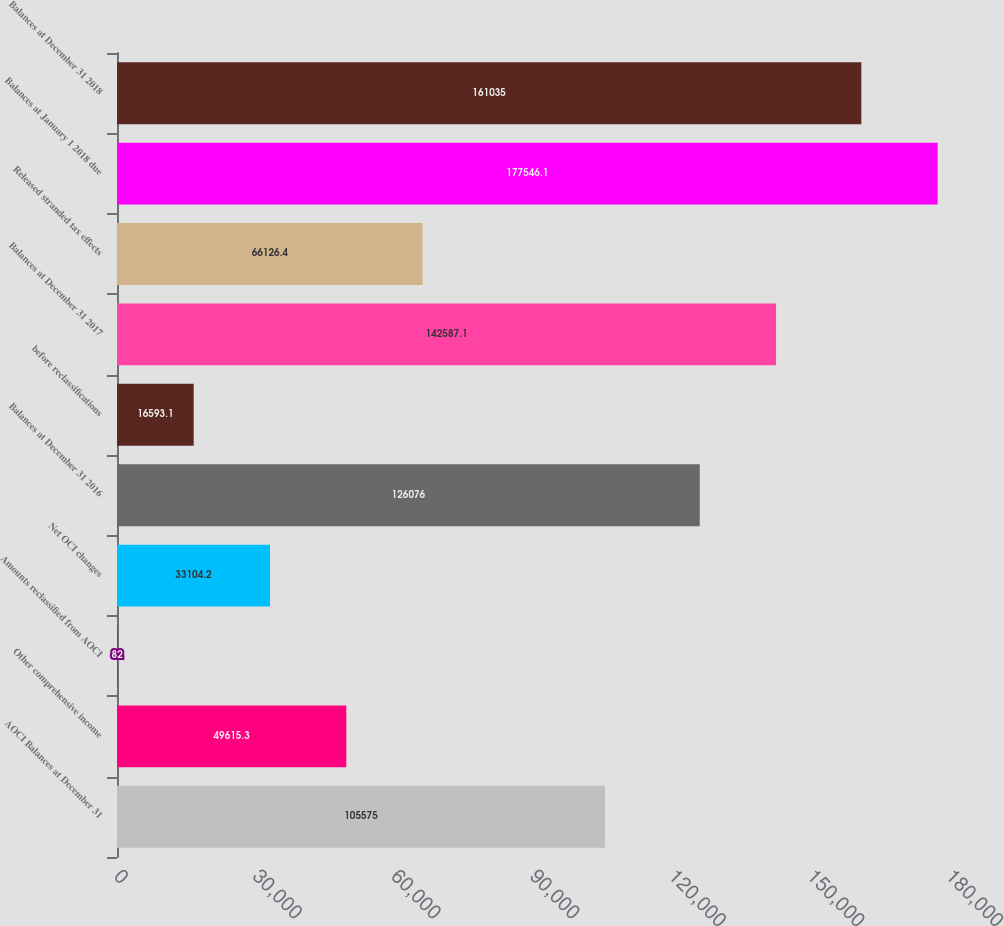Convert chart to OTSL. <chart><loc_0><loc_0><loc_500><loc_500><bar_chart><fcel>AOCI Balances at December 31<fcel>Other comprehensive income<fcel>Amounts reclassified from AOCI<fcel>Net OCI changes<fcel>Balances at December 31 2016<fcel>before reclassifications<fcel>Balances at December 31 2017<fcel>Released stranded tax effects<fcel>Balances at January 1 2018 due<fcel>Balances at December 31 2018<nl><fcel>105575<fcel>49615.3<fcel>82<fcel>33104.2<fcel>126076<fcel>16593.1<fcel>142587<fcel>66126.4<fcel>177546<fcel>161035<nl></chart> 